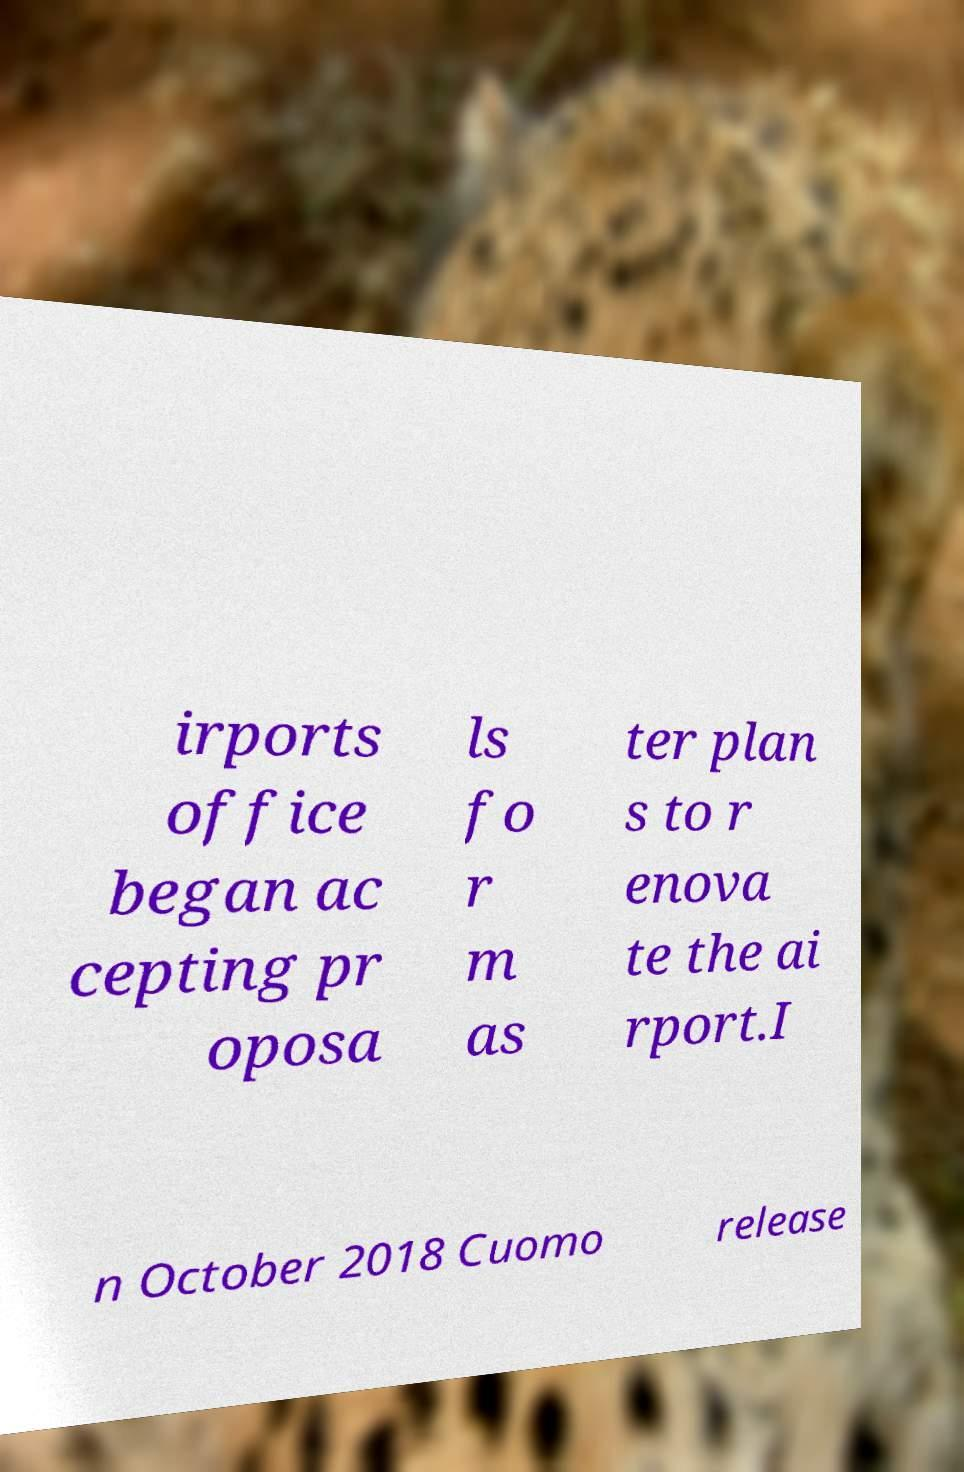Can you read and provide the text displayed in the image?This photo seems to have some interesting text. Can you extract and type it out for me? irports office began ac cepting pr oposa ls fo r m as ter plan s to r enova te the ai rport.I n October 2018 Cuomo release 